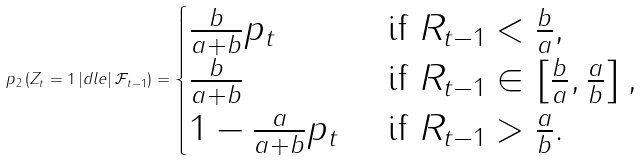<formula> <loc_0><loc_0><loc_500><loc_500>\ p _ { 2 } \left ( Z _ { t } = 1 \, | d l e | \, \mathcal { F } _ { t - 1 } \right ) = \begin{cases} \frac { b } { a + b } p _ { t } & \text { if } R _ { t - 1 } < \frac { b } { a } , \\ \frac { b } { a + b } & \text { if } R _ { t - 1 } \in \left [ \frac { b } { a } , \frac { a } { b } \right ] , \\ 1 - \frac { a } { a + b } p _ { t } & \text { if } R _ { t - 1 } > \frac { a } { b } . \end{cases}</formula> 